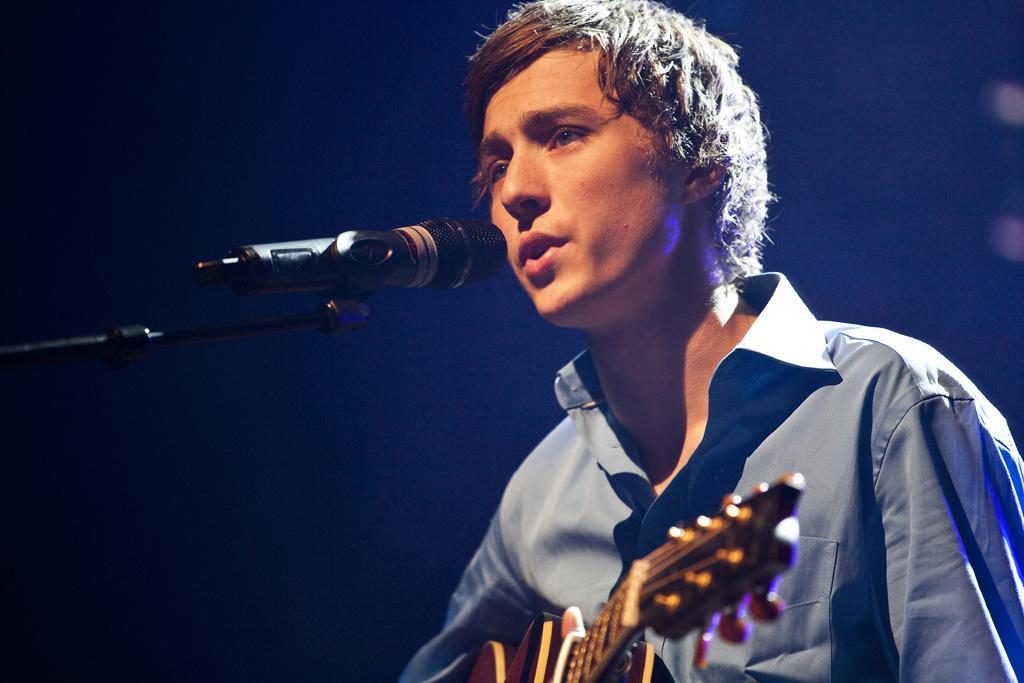Could you give a brief overview of what you see in this image? In this image we can see a man holding musical instrument and a mic is placed in front of him. 